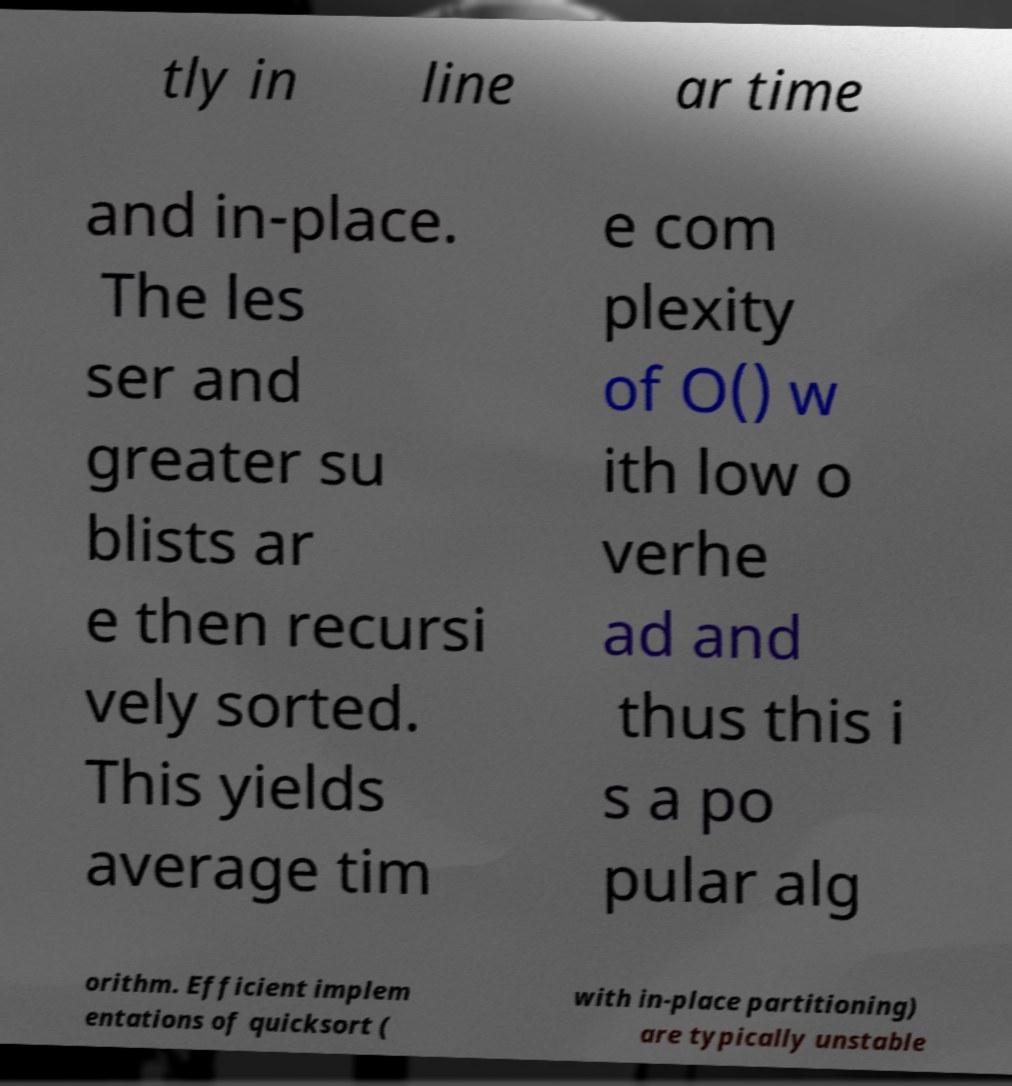Could you extract and type out the text from this image? tly in line ar time and in-place. The les ser and greater su blists ar e then recursi vely sorted. This yields average tim e com plexity of O() w ith low o verhe ad and thus this i s a po pular alg orithm. Efficient implem entations of quicksort ( with in-place partitioning) are typically unstable 